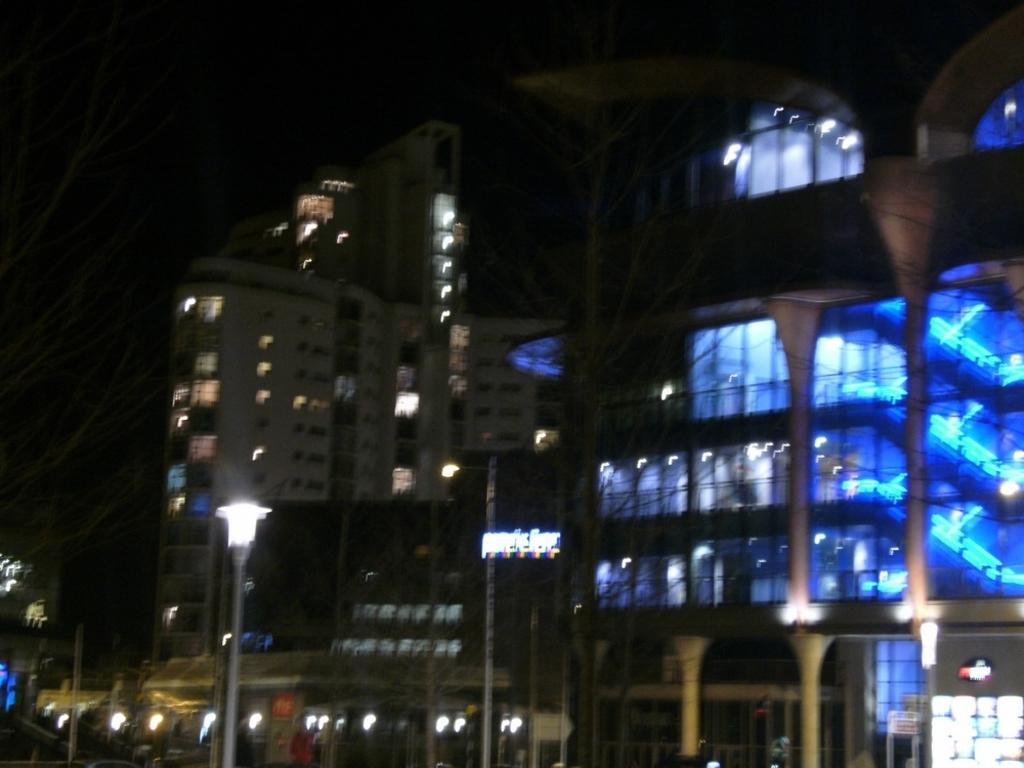What structures are present in the image? There are buildings in the image. What feature can be observed on the buildings? The buildings have lights. What type of lighting is present along the street in the image? There is a street light in the image. How many rings are visible on the roof of the building in the image? There are no rings visible on the roof of the building in the image. What type of current is powering the lights on the buildings in the image? The image does not provide information about the type of current powering the lights on the buildings. 